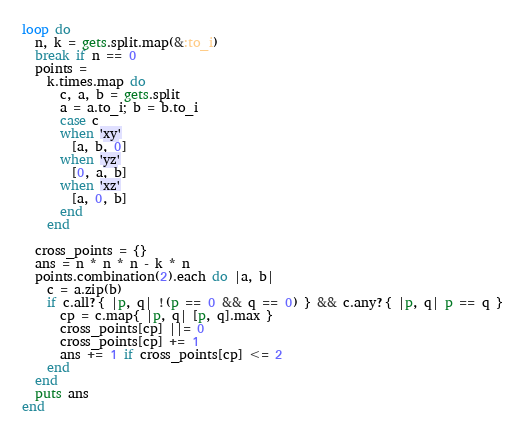<code> <loc_0><loc_0><loc_500><loc_500><_Ruby_>loop do
  n, k = gets.split.map(&:to_i)
  break if n == 0
  points =
    k.times.map do
      c, a, b = gets.split
      a = a.to_i; b = b.to_i
      case c
      when 'xy'
        [a, b, 0]
      when 'yz'
        [0, a, b]
      when 'xz'
        [a, 0, b]
      end
    end
 
  cross_points = {}
  ans = n * n * n - k * n
  points.combination(2).each do |a, b|
    c = a.zip(b)
    if c.all?{ |p, q| !(p == 0 && q == 0) } && c.any?{ |p, q| p == q }
      cp = c.map{ |p, q| [p, q].max }
      cross_points[cp] ||= 0
      cross_points[cp] += 1
      ans += 1 if cross_points[cp] <= 2
    end
  end
  puts ans
end</code> 